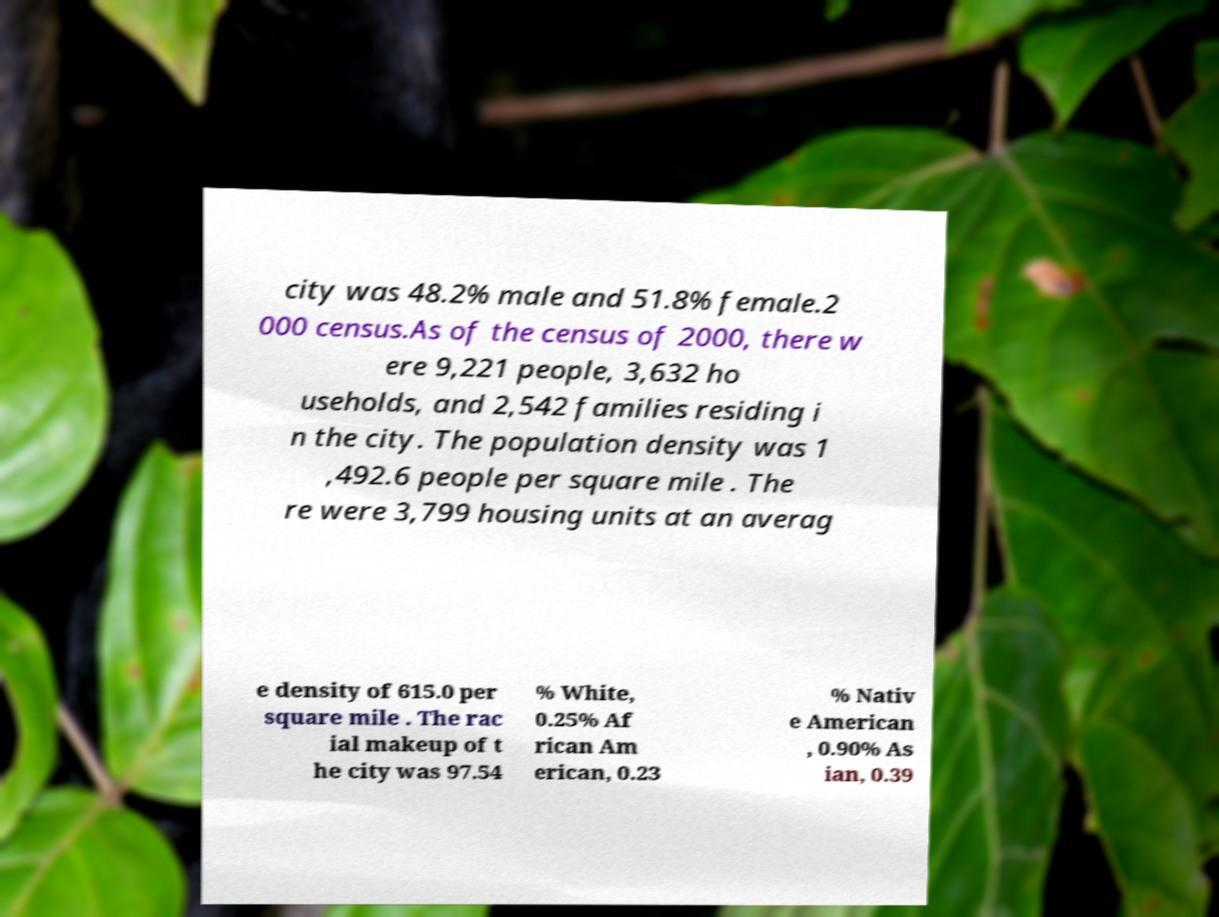Can you read and provide the text displayed in the image?This photo seems to have some interesting text. Can you extract and type it out for me? city was 48.2% male and 51.8% female.2 000 census.As of the census of 2000, there w ere 9,221 people, 3,632 ho useholds, and 2,542 families residing i n the city. The population density was 1 ,492.6 people per square mile . The re were 3,799 housing units at an averag e density of 615.0 per square mile . The rac ial makeup of t he city was 97.54 % White, 0.25% Af rican Am erican, 0.23 % Nativ e American , 0.90% As ian, 0.39 